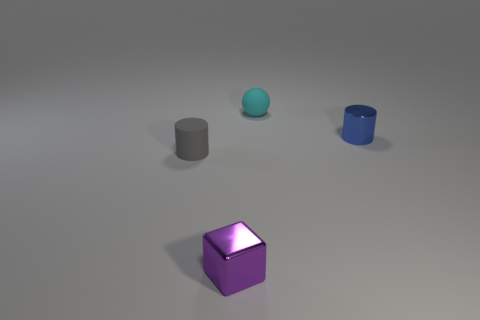Add 3 cylinders. How many objects exist? 7 Subtract all spheres. How many objects are left? 3 Add 4 cyan rubber things. How many cyan rubber things exist? 5 Subtract 0 red cylinders. How many objects are left? 4 Subtract all small blue metallic cylinders. Subtract all blue shiny things. How many objects are left? 2 Add 4 gray rubber cylinders. How many gray rubber cylinders are left? 5 